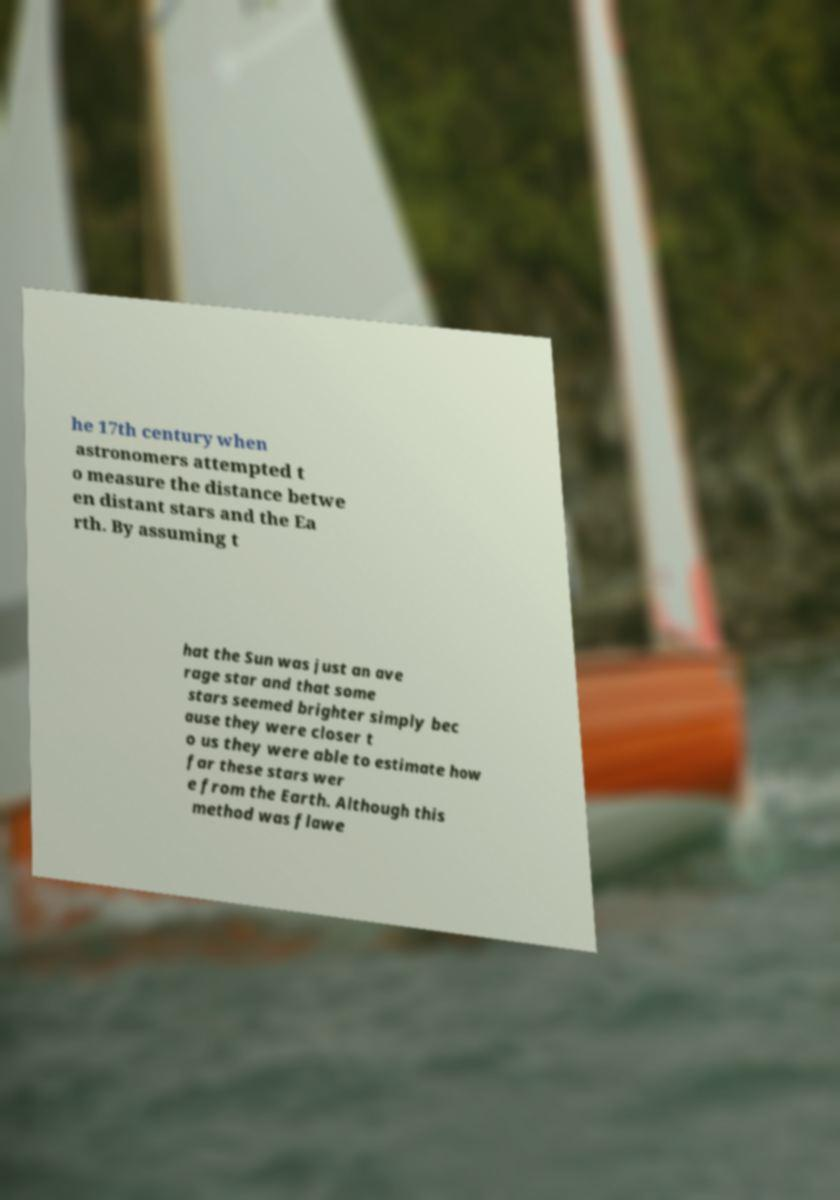Could you assist in decoding the text presented in this image and type it out clearly? he 17th century when astronomers attempted t o measure the distance betwe en distant stars and the Ea rth. By assuming t hat the Sun was just an ave rage star and that some stars seemed brighter simply bec ause they were closer t o us they were able to estimate how far these stars wer e from the Earth. Although this method was flawe 